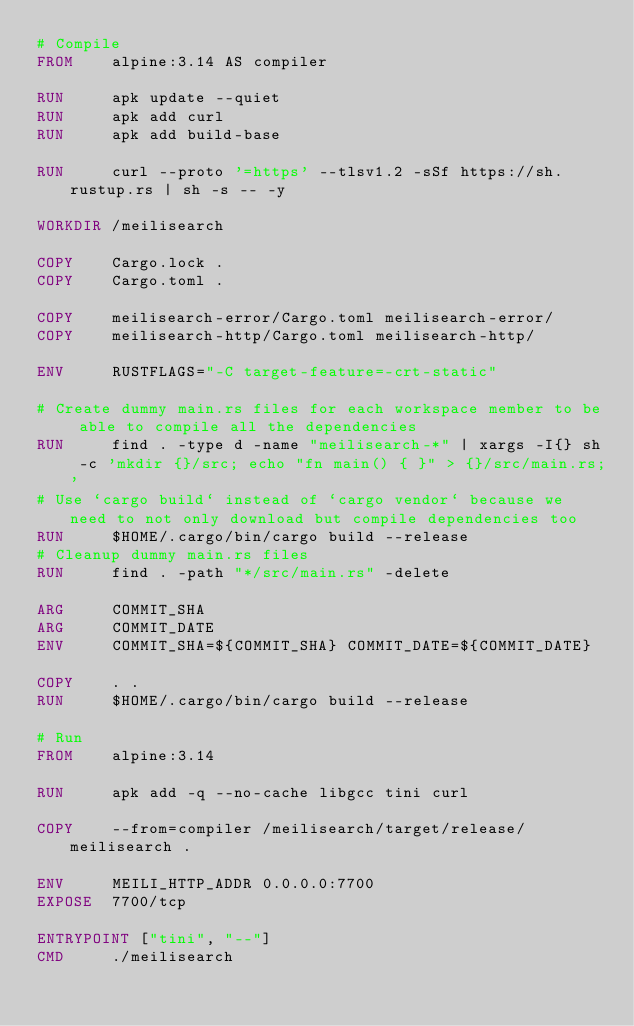<code> <loc_0><loc_0><loc_500><loc_500><_Dockerfile_># Compile
FROM    alpine:3.14 AS compiler

RUN     apk update --quiet
RUN     apk add curl
RUN     apk add build-base

RUN     curl --proto '=https' --tlsv1.2 -sSf https://sh.rustup.rs | sh -s -- -y

WORKDIR /meilisearch

COPY    Cargo.lock .
COPY    Cargo.toml .

COPY    meilisearch-error/Cargo.toml meilisearch-error/
COPY    meilisearch-http/Cargo.toml meilisearch-http/

ENV     RUSTFLAGS="-C target-feature=-crt-static"

# Create dummy main.rs files for each workspace member to be able to compile all the dependencies
RUN     find . -type d -name "meilisearch-*" | xargs -I{} sh -c 'mkdir {}/src; echo "fn main() { }" > {}/src/main.rs;'
# Use `cargo build` instead of `cargo vendor` because we need to not only download but compile dependencies too
RUN     $HOME/.cargo/bin/cargo build --release
# Cleanup dummy main.rs files
RUN     find . -path "*/src/main.rs" -delete

ARG     COMMIT_SHA
ARG     COMMIT_DATE
ENV     COMMIT_SHA=${COMMIT_SHA} COMMIT_DATE=${COMMIT_DATE}

COPY    . .
RUN     $HOME/.cargo/bin/cargo build --release

# Run
FROM    alpine:3.14

RUN     apk add -q --no-cache libgcc tini curl

COPY    --from=compiler /meilisearch/target/release/meilisearch .

ENV     MEILI_HTTP_ADDR 0.0.0.0:7700
EXPOSE  7700/tcp

ENTRYPOINT ["tini", "--"]
CMD     ./meilisearch
</code> 